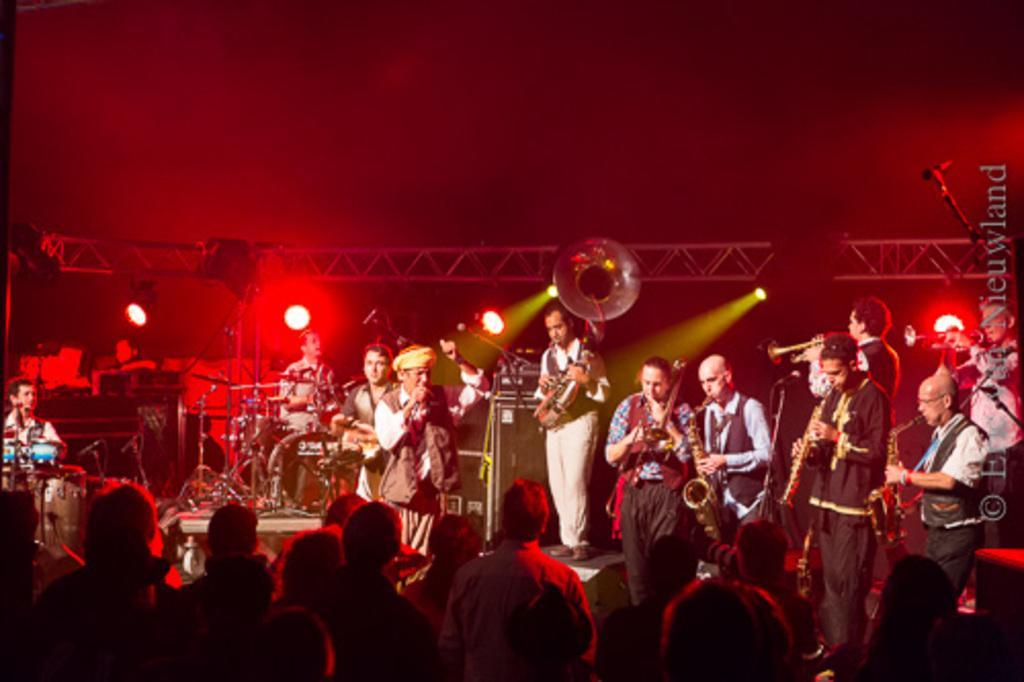Describe this image in one or two sentences. Here in this picture we can see a group of people standing on the stage and they are playing their own musical instruments present with them and the person in the middle is singing a song with microphone in his hands and behind them we can see colorful lights present on the iron frame over there and in front of them we can see number of people standing and watching them performing. 